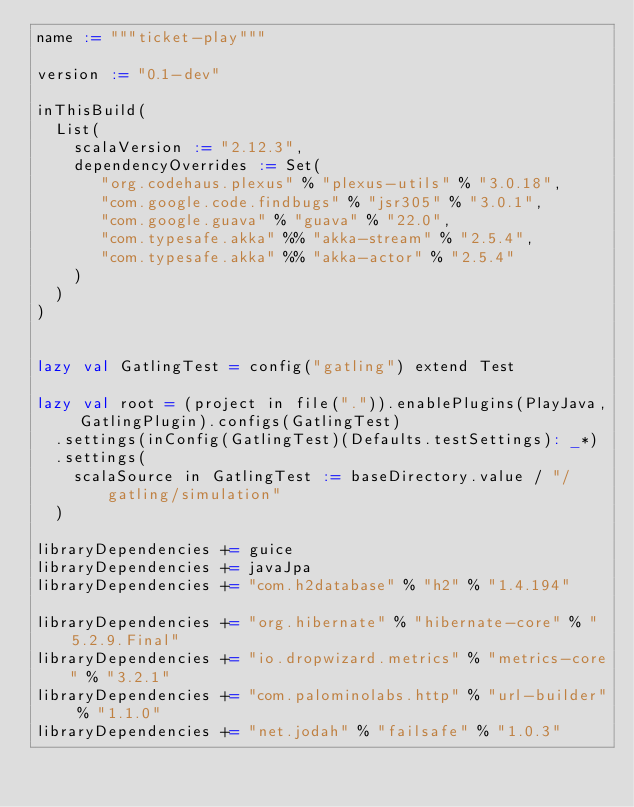<code> <loc_0><loc_0><loc_500><loc_500><_Scala_>name := """ticket-play"""

version := "0.1-dev"

inThisBuild(
  List(
    scalaVersion := "2.12.3",
    dependencyOverrides := Set(
       "org.codehaus.plexus" % "plexus-utils" % "3.0.18",
       "com.google.code.findbugs" % "jsr305" % "3.0.1",
       "com.google.guava" % "guava" % "22.0",
       "com.typesafe.akka" %% "akka-stream" % "2.5.4",
       "com.typesafe.akka" %% "akka-actor" % "2.5.4"
    )
  )
)


lazy val GatlingTest = config("gatling") extend Test

lazy val root = (project in file(".")).enablePlugins(PlayJava, GatlingPlugin).configs(GatlingTest)
  .settings(inConfig(GatlingTest)(Defaults.testSettings): _*)
  .settings(
    scalaSource in GatlingTest := baseDirectory.value / "/gatling/simulation"
  )

libraryDependencies += guice
libraryDependencies += javaJpa
libraryDependencies += "com.h2database" % "h2" % "1.4.194"

libraryDependencies += "org.hibernate" % "hibernate-core" % "5.2.9.Final"
libraryDependencies += "io.dropwizard.metrics" % "metrics-core" % "3.2.1"
libraryDependencies += "com.palominolabs.http" % "url-builder" % "1.1.0"
libraryDependencies += "net.jodah" % "failsafe" % "1.0.3"
</code> 